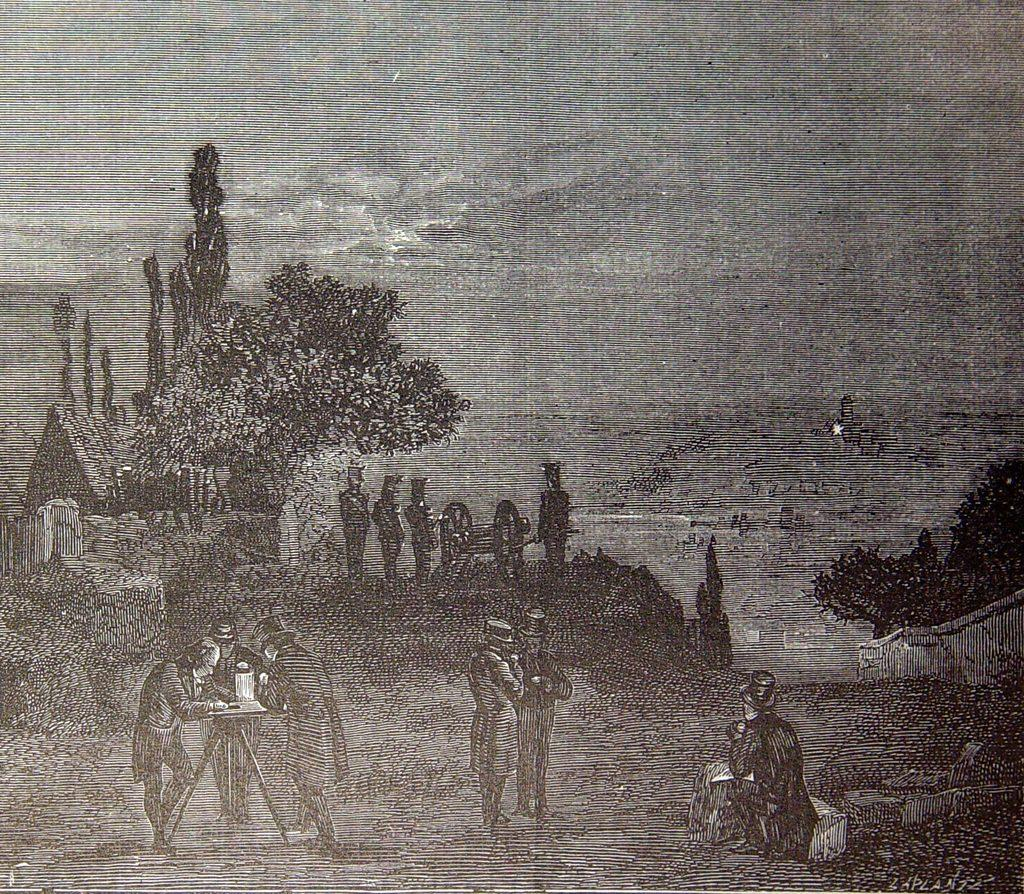Who or what is present in the image? There are people in the image. What is located on the left side of the image? There is a table on the left side of the image. What can be seen in the background of the image? There is a shed, trees, and the sky visible in the background of the image. What is on the right side of the image? There is a fence on the right side of the image. How many thumbs can be seen on the people in the image? There is no way to determine the number of thumbs on the people in the image, as it is not possible to see the palms of their hands. 